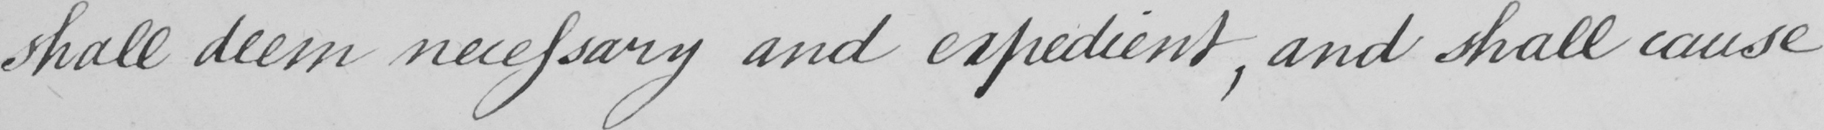Please provide the text content of this handwritten line. shall deem necessary and expedient, and shall cause 